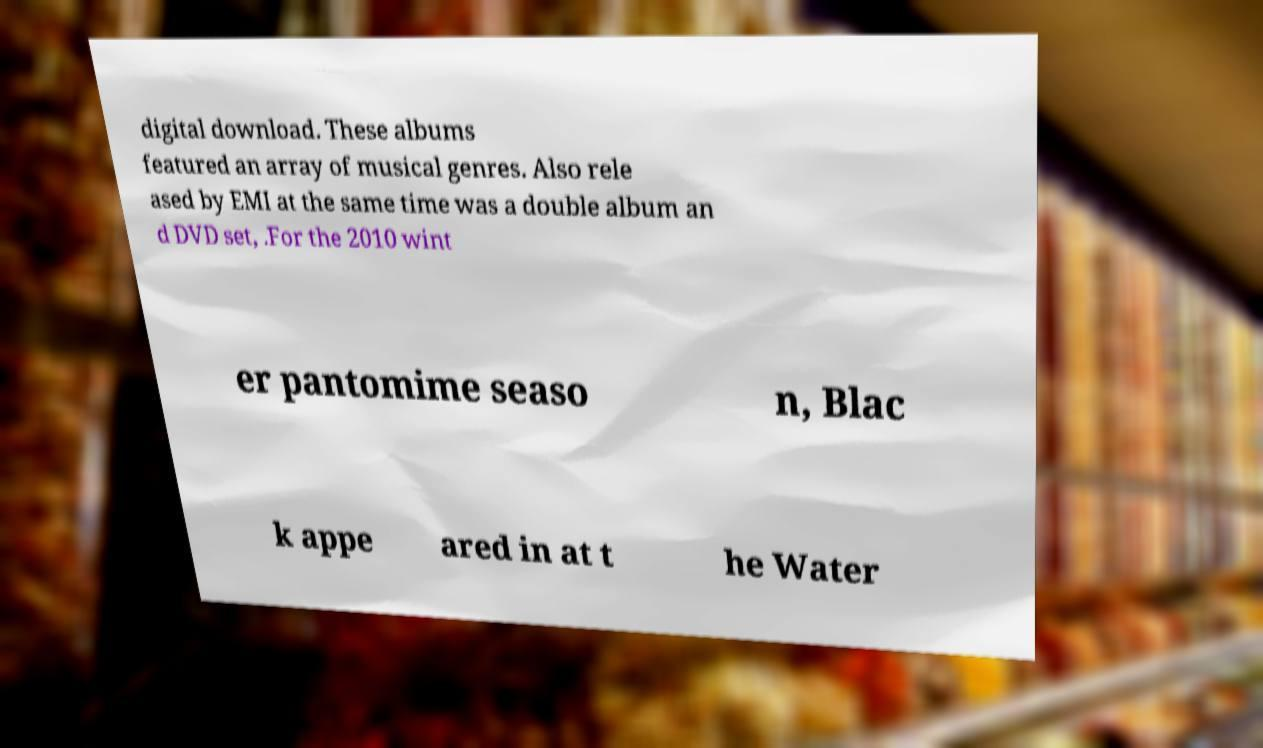For documentation purposes, I need the text within this image transcribed. Could you provide that? digital download. These albums featured an array of musical genres. Also rele ased by EMI at the same time was a double album an d DVD set, .For the 2010 wint er pantomime seaso n, Blac k appe ared in at t he Water 